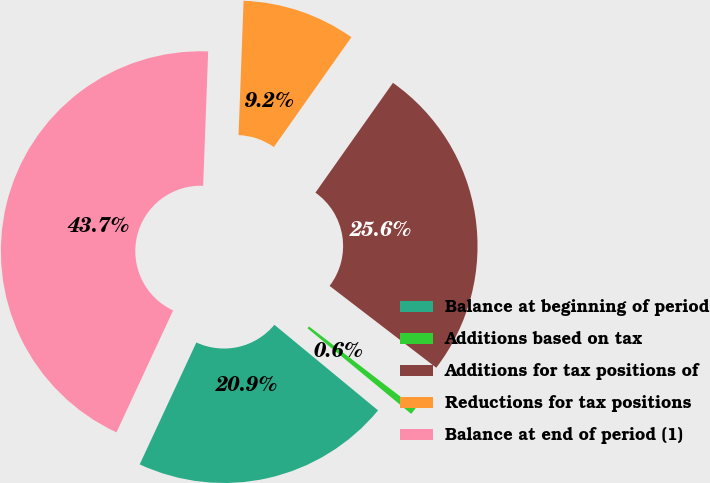Convert chart to OTSL. <chart><loc_0><loc_0><loc_500><loc_500><pie_chart><fcel>Balance at beginning of period<fcel>Additions based on tax<fcel>Additions for tax positions of<fcel>Reductions for tax positions<fcel>Balance at end of period (1)<nl><fcel>20.94%<fcel>0.57%<fcel>25.63%<fcel>9.19%<fcel>43.67%<nl></chart> 